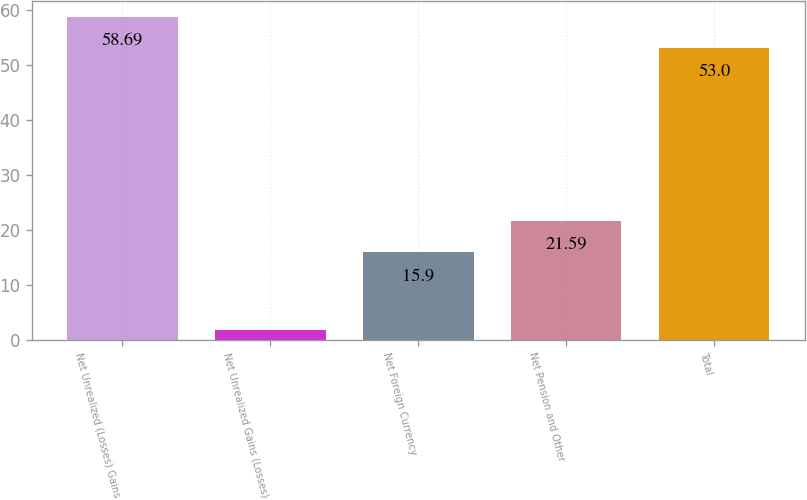Convert chart. <chart><loc_0><loc_0><loc_500><loc_500><bar_chart><fcel>Net Unrealized (Losses) Gains<fcel>Net Unrealized Gains (Losses)<fcel>Net Foreign Currency<fcel>Net Pension and Other<fcel>Total<nl><fcel>58.69<fcel>1.7<fcel>15.9<fcel>21.59<fcel>53<nl></chart> 